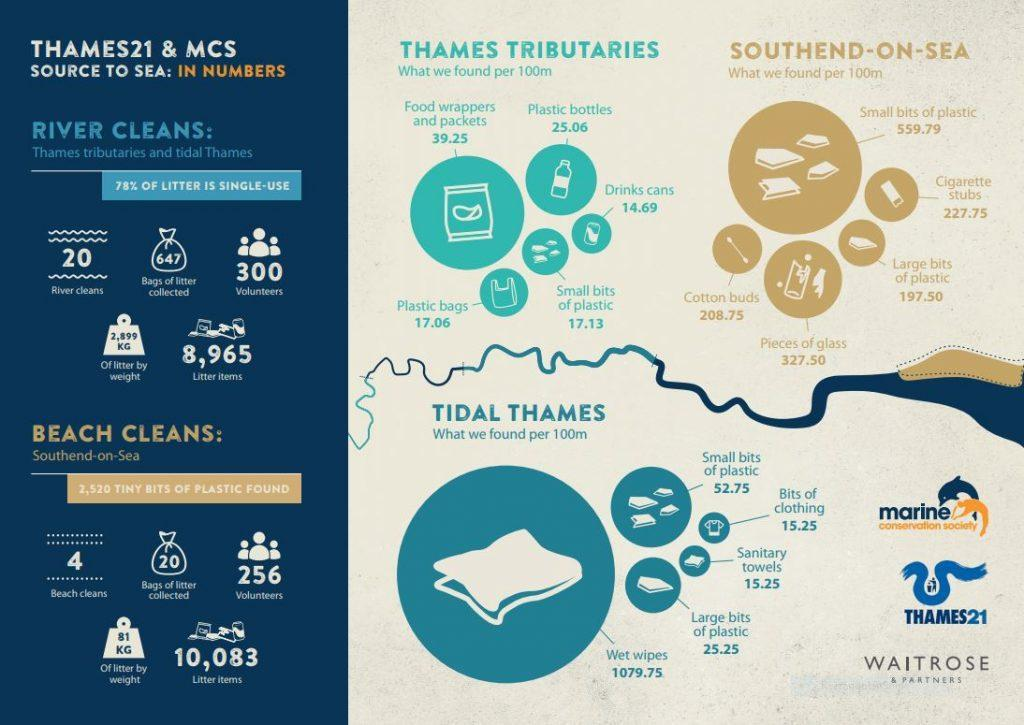What is the total number of litter items both from rivers and beaches?
Answer the question with a short phrase. 19048 What is the number of bags of litter collected? 647 What is the total number of rivers and beaches cleaned? 24 What is the total number of bags of litter collected both from rivers and beaches? 667 